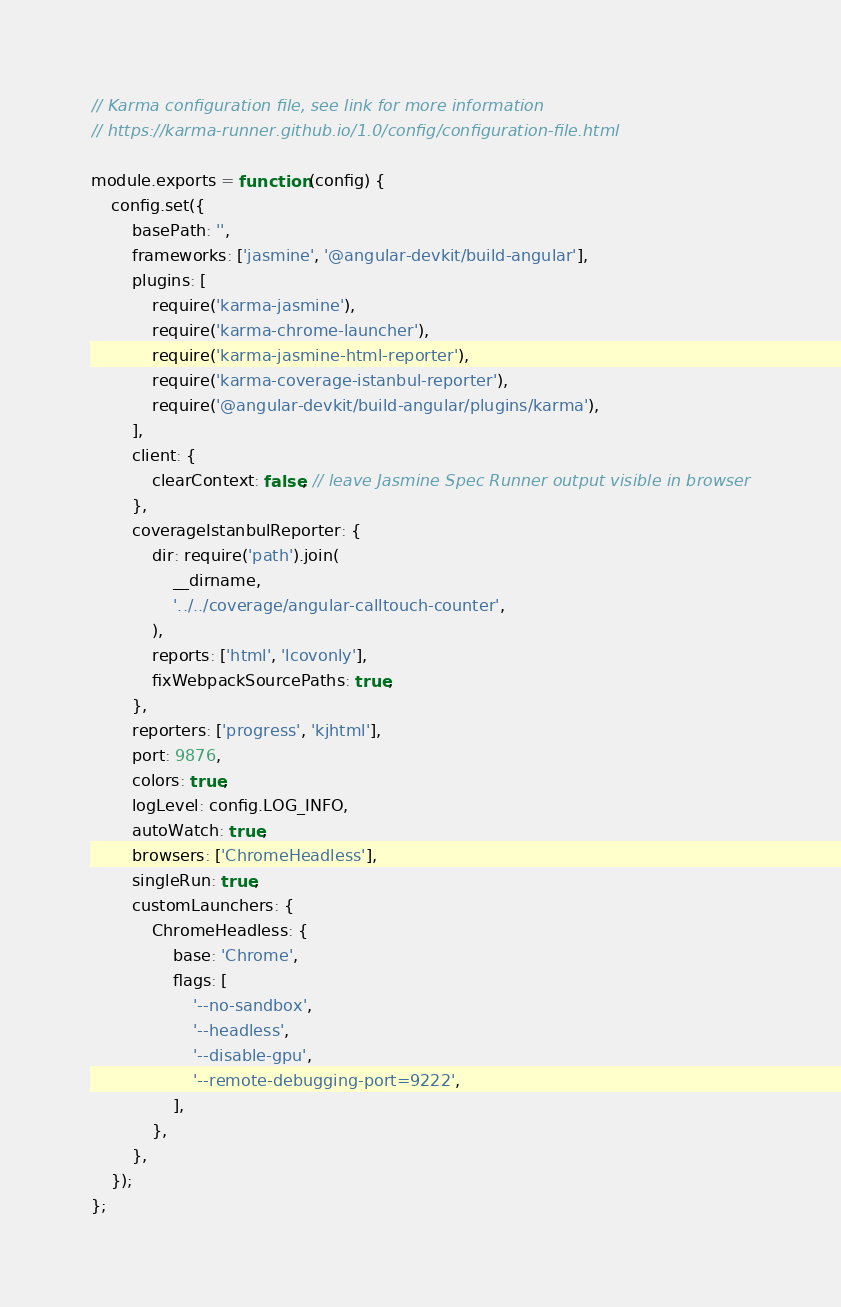Convert code to text. <code><loc_0><loc_0><loc_500><loc_500><_JavaScript_>// Karma configuration file, see link for more information
// https://karma-runner.github.io/1.0/config/configuration-file.html

module.exports = function (config) {
    config.set({
        basePath: '',
        frameworks: ['jasmine', '@angular-devkit/build-angular'],
        plugins: [
            require('karma-jasmine'),
            require('karma-chrome-launcher'),
            require('karma-jasmine-html-reporter'),
            require('karma-coverage-istanbul-reporter'),
            require('@angular-devkit/build-angular/plugins/karma'),
        ],
        client: {
            clearContext: false, // leave Jasmine Spec Runner output visible in browser
        },
        coverageIstanbulReporter: {
            dir: require('path').join(
                __dirname,
                '../../coverage/angular-calltouch-counter',
            ),
            reports: ['html', 'lcovonly'],
            fixWebpackSourcePaths: true,
        },
        reporters: ['progress', 'kjhtml'],
        port: 9876,
        colors: true,
        logLevel: config.LOG_INFO,
        autoWatch: true,
        browsers: ['ChromeHeadless'],
        singleRun: true,
        customLaunchers: {
            ChromeHeadless: {
                base: 'Chrome',
                flags: [
                    '--no-sandbox',
                    '--headless',
                    '--disable-gpu',
                    '--remote-debugging-port=9222',
                ],
            },
        },
    });
};
</code> 